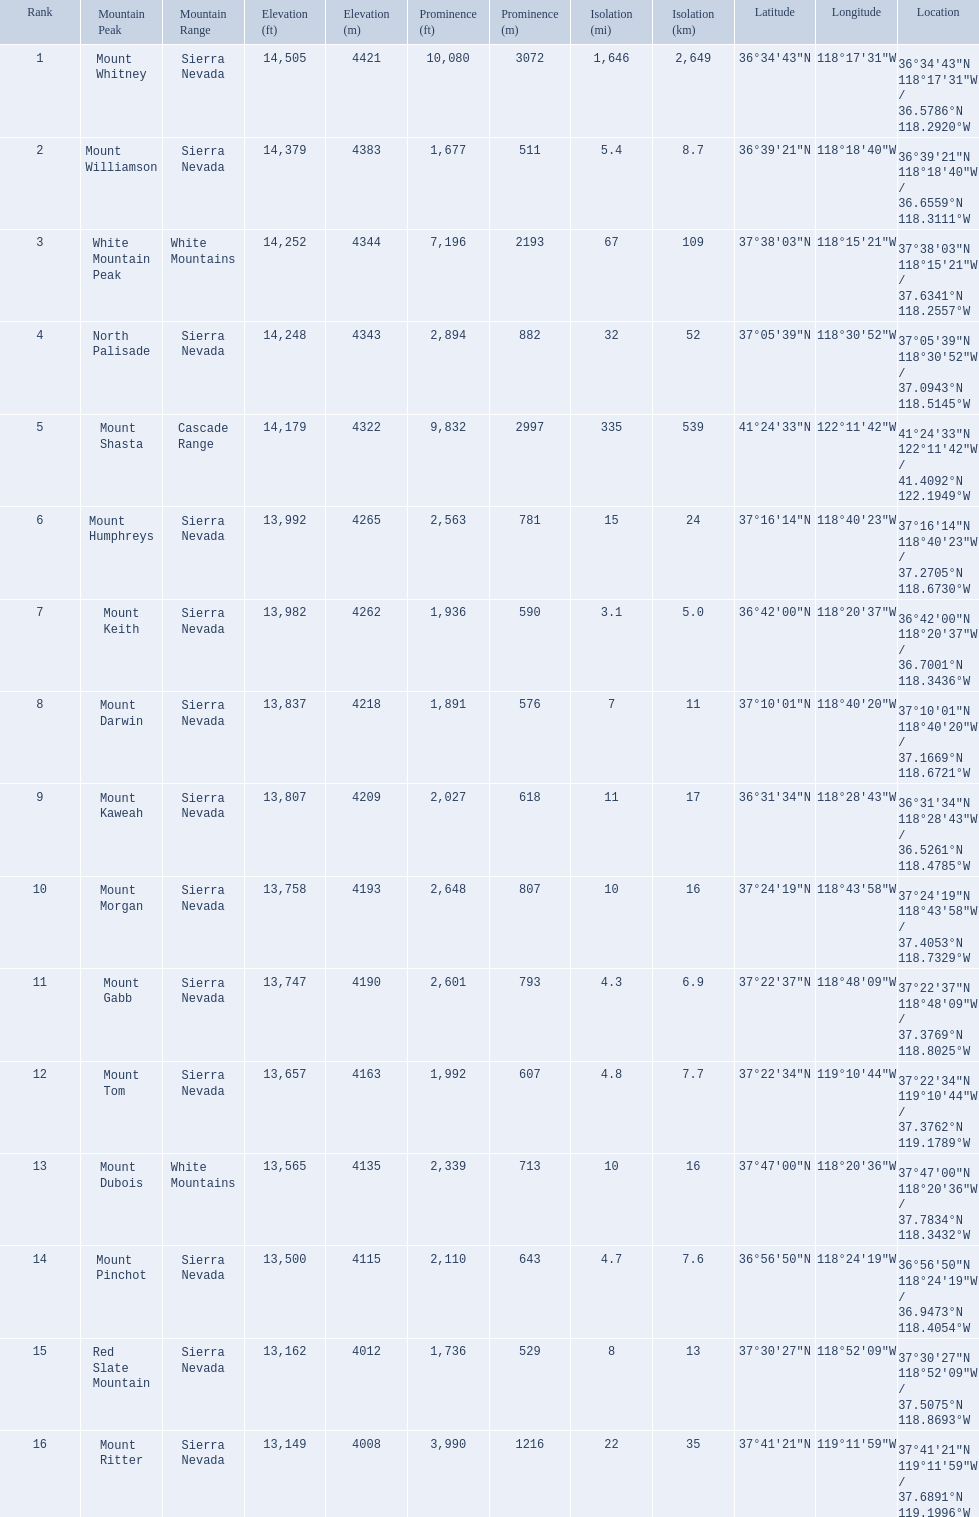What are the heights of the peaks? 14,505 ft\n4421 m, 14,379 ft\n4383 m, 14,252 ft\n4344 m, 14,248 ft\n4343 m, 14,179 ft\n4322 m, 13,992 ft\n4265 m, 13,982 ft\n4262 m, 13,837 ft\n4218 m, 13,807 ft\n4209 m, 13,758 ft\n4193 m, 13,747 ft\n4190 m, 13,657 ft\n4163 m, 13,565 ft\n4135 m, 13,500 ft\n4115 m, 13,162 ft\n4012 m, 13,149 ft\n4008 m. Would you be able to parse every entry in this table? {'header': ['Rank', 'Mountain Peak', 'Mountain Range', 'Elevation (ft)', 'Elevation (m)', 'Prominence (ft)', 'Prominence (m)', 'Isolation (mi)', 'Isolation (km)', 'Latitude', 'Longitude', 'Location'], 'rows': [['1', 'Mount Whitney', 'Sierra Nevada', '14,505', '4421', '10,080', '3072', '1,646', '2,649', '36°34′43″N', '118°17′31″W\ufeff', '36°34′43″N 118°17′31″W\ufeff / \ufeff36.5786°N 118.2920°W'], ['2', 'Mount Williamson', 'Sierra Nevada', '14,379', '4383', '1,677', '511', '5.4', '8.7', '36°39′21″N', '118°18′40″W\ufeff', '36°39′21″N 118°18′40″W\ufeff / \ufeff36.6559°N 118.3111°W'], ['3', 'White Mountain Peak', 'White Mountains', '14,252', '4344', '7,196', '2193', '67', '109', '37°38′03″N', '118°15′21″W\ufeff', '37°38′03″N 118°15′21″W\ufeff / \ufeff37.6341°N 118.2557°W'], ['4', 'North Palisade', 'Sierra Nevada', '14,248', '4343', '2,894', '882', '32', '52', '37°05′39″N', '118°30′52″W\ufeff', '37°05′39″N 118°30′52″W\ufeff / \ufeff37.0943°N 118.5145°W'], ['5', 'Mount Shasta', 'Cascade Range', '14,179', '4322', '9,832', '2997', '335', '539', '41°24′33″N', '122°11′42″W\ufeff', '41°24′33″N 122°11′42″W\ufeff / \ufeff41.4092°N 122.1949°W'], ['6', 'Mount Humphreys', 'Sierra Nevada', '13,992', '4265', '2,563', '781', '15', '24', '37°16′14″N', '118°40′23″W\ufeff', '37°16′14″N 118°40′23″W\ufeff / \ufeff37.2705°N 118.6730°W'], ['7', 'Mount Keith', 'Sierra Nevada', '13,982', '4262', '1,936', '590', '3.1', '5.0', '36°42′00″N', '118°20′37″W\ufeff', '36°42′00″N 118°20′37″W\ufeff / \ufeff36.7001°N 118.3436°W'], ['8', 'Mount Darwin', 'Sierra Nevada', '13,837', '4218', '1,891', '576', '7', '11', '37°10′01″N', '118°40′20″W\ufeff', '37°10′01″N 118°40′20″W\ufeff / \ufeff37.1669°N 118.6721°W'], ['9', 'Mount Kaweah', 'Sierra Nevada', '13,807', '4209', '2,027', '618', '11', '17', '36°31′34″N', '118°28′43″W\ufeff', '36°31′34″N 118°28′43″W\ufeff / \ufeff36.5261°N 118.4785°W'], ['10', 'Mount Morgan', 'Sierra Nevada', '13,758', '4193', '2,648', '807', '10', '16', '37°24′19″N', '118°43′58″W\ufeff', '37°24′19″N 118°43′58″W\ufeff / \ufeff37.4053°N 118.7329°W'], ['11', 'Mount Gabb', 'Sierra Nevada', '13,747', '4190', '2,601', '793', '4.3', '6.9', '37°22′37″N', '118°48′09″W\ufeff', '37°22′37″N 118°48′09″W\ufeff / \ufeff37.3769°N 118.8025°W'], ['12', 'Mount Tom', 'Sierra Nevada', '13,657', '4163', '1,992', '607', '4.8', '7.7', '37°22′34″N', '119°10′44″W\ufeff', '37°22′34″N 119°10′44″W\ufeff / \ufeff37.3762°N 119.1789°W'], ['13', 'Mount Dubois', 'White Mountains', '13,565', '4135', '2,339', '713', '10', '16', '37°47′00″N', '118°20′36″W\ufeff', '37°47′00″N 118°20′36″W\ufeff / \ufeff37.7834°N 118.3432°W'], ['14', 'Mount Pinchot', 'Sierra Nevada', '13,500', '4115', '2,110', '643', '4.7', '7.6', '36°56′50″N', '118°24′19″W\ufeff', '36°56′50″N 118°24′19″W\ufeff / \ufeff36.9473°N 118.4054°W'], ['15', 'Red Slate Mountain', 'Sierra Nevada', '13,162', '4012', '1,736', '529', '8', '13', '37°30′27″N', '118°52′09″W\ufeff', '37°30′27″N 118°52′09″W\ufeff / \ufeff37.5075°N 118.8693°W'], ['16', 'Mount Ritter', 'Sierra Nevada', '13,149', '4008', '3,990', '1216', '22', '35', '37°41′21″N', '119°11′59″W\ufeff', '37°41′21″N 119°11′59″W\ufeff / \ufeff37.6891°N 119.1996°W']]} Which of these heights is tallest? 14,505 ft\n4421 m. What peak is 14,505 feet? Mount Whitney. 